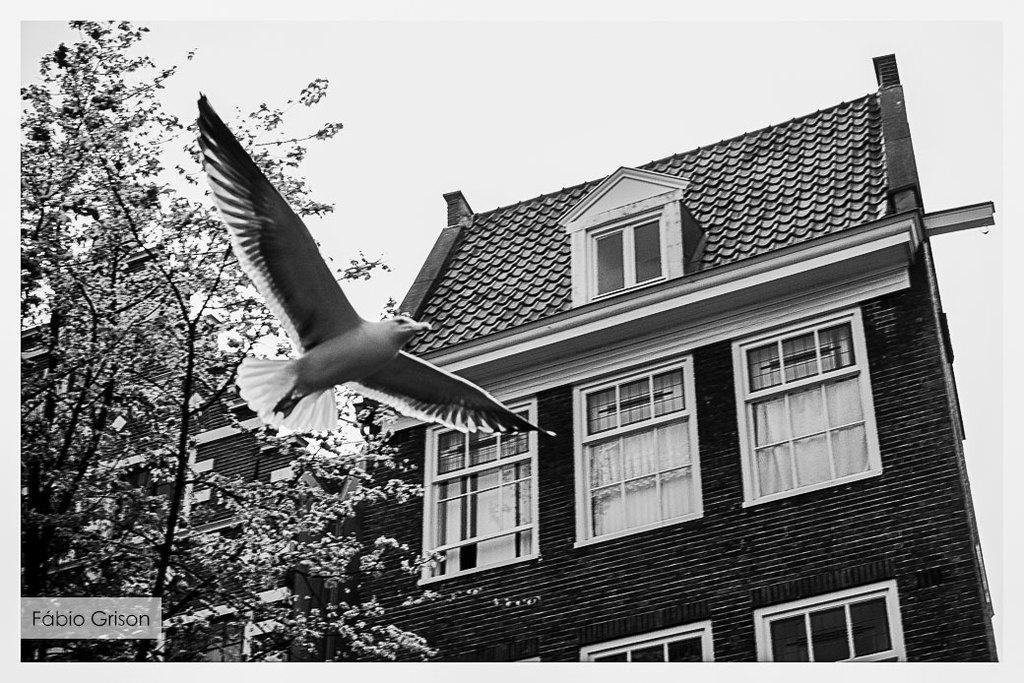Could you give a brief overview of what you see in this image? In this picture, there is a bird flying on the right side there is a house and on the left side there is a tree. 